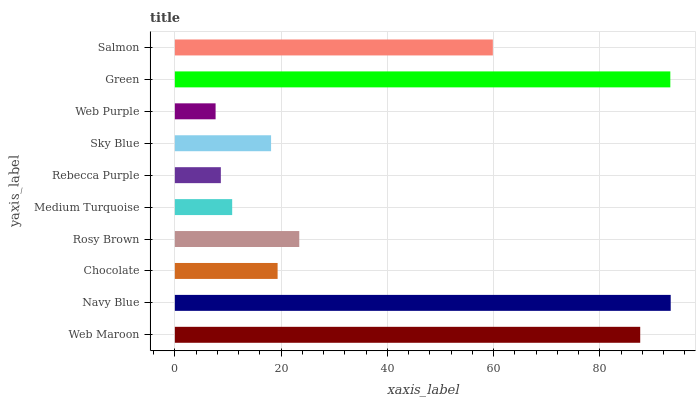Is Web Purple the minimum?
Answer yes or no. Yes. Is Navy Blue the maximum?
Answer yes or no. Yes. Is Chocolate the minimum?
Answer yes or no. No. Is Chocolate the maximum?
Answer yes or no. No. Is Navy Blue greater than Chocolate?
Answer yes or no. Yes. Is Chocolate less than Navy Blue?
Answer yes or no. Yes. Is Chocolate greater than Navy Blue?
Answer yes or no. No. Is Navy Blue less than Chocolate?
Answer yes or no. No. Is Rosy Brown the high median?
Answer yes or no. Yes. Is Chocolate the low median?
Answer yes or no. Yes. Is Navy Blue the high median?
Answer yes or no. No. Is Web Purple the low median?
Answer yes or no. No. 